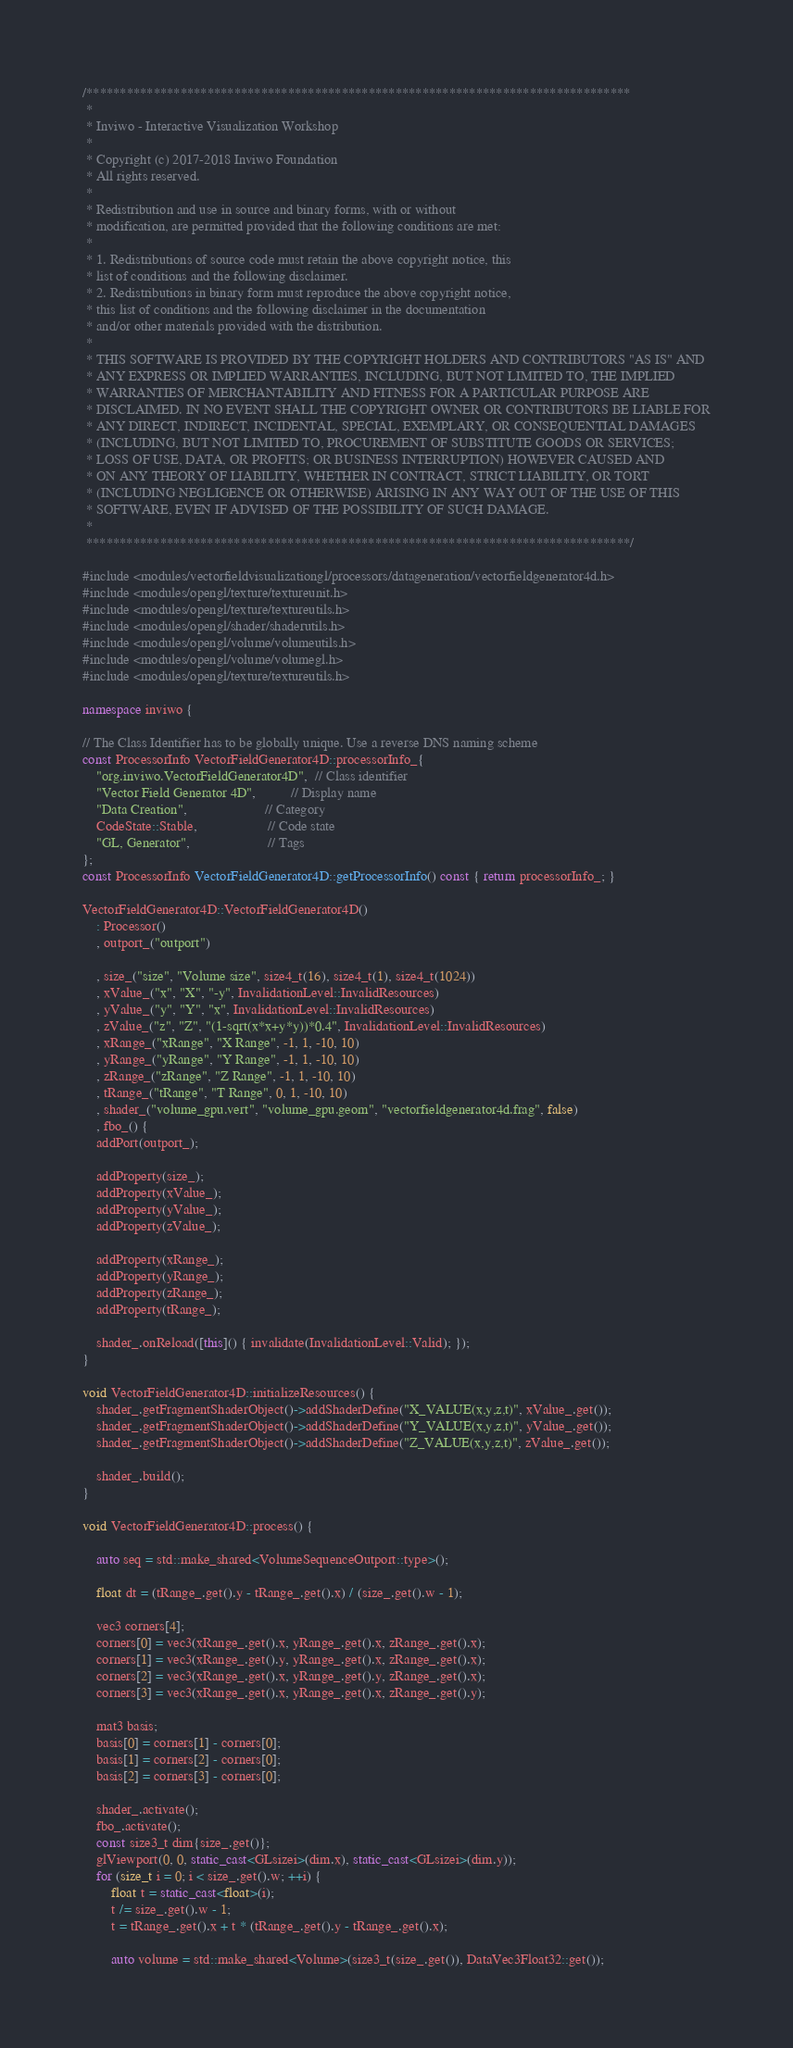<code> <loc_0><loc_0><loc_500><loc_500><_C++_>/*********************************************************************************
 *
 * Inviwo - Interactive Visualization Workshop
 *
 * Copyright (c) 2017-2018 Inviwo Foundation
 * All rights reserved.
 *
 * Redistribution and use in source and binary forms, with or without
 * modification, are permitted provided that the following conditions are met:
 *
 * 1. Redistributions of source code must retain the above copyright notice, this
 * list of conditions and the following disclaimer.
 * 2. Redistributions in binary form must reproduce the above copyright notice,
 * this list of conditions and the following disclaimer in the documentation
 * and/or other materials provided with the distribution.
 *
 * THIS SOFTWARE IS PROVIDED BY THE COPYRIGHT HOLDERS AND CONTRIBUTORS "AS IS" AND
 * ANY EXPRESS OR IMPLIED WARRANTIES, INCLUDING, BUT NOT LIMITED TO, THE IMPLIED
 * WARRANTIES OF MERCHANTABILITY AND FITNESS FOR A PARTICULAR PURPOSE ARE
 * DISCLAIMED. IN NO EVENT SHALL THE COPYRIGHT OWNER OR CONTRIBUTORS BE LIABLE FOR
 * ANY DIRECT, INDIRECT, INCIDENTAL, SPECIAL, EXEMPLARY, OR CONSEQUENTIAL DAMAGES
 * (INCLUDING, BUT NOT LIMITED TO, PROCUREMENT OF SUBSTITUTE GOODS OR SERVICES;
 * LOSS OF USE, DATA, OR PROFITS; OR BUSINESS INTERRUPTION) HOWEVER CAUSED AND
 * ON ANY THEORY OF LIABILITY, WHETHER IN CONTRACT, STRICT LIABILITY, OR TORT
 * (INCLUDING NEGLIGENCE OR OTHERWISE) ARISING IN ANY WAY OUT OF THE USE OF THIS
 * SOFTWARE, EVEN IF ADVISED OF THE POSSIBILITY OF SUCH DAMAGE.
 *
 *********************************************************************************/

#include <modules/vectorfieldvisualizationgl/processors/datageneration/vectorfieldgenerator4d.h>
#include <modules/opengl/texture/textureunit.h>
#include <modules/opengl/texture/textureutils.h>
#include <modules/opengl/shader/shaderutils.h>
#include <modules/opengl/volume/volumeutils.h>
#include <modules/opengl/volume/volumegl.h>
#include <modules/opengl/texture/textureutils.h>

namespace inviwo {

// The Class Identifier has to be globally unique. Use a reverse DNS naming scheme
const ProcessorInfo VectorFieldGenerator4D::processorInfo_{
    "org.inviwo.VectorFieldGenerator4D",  // Class identifier
    "Vector Field Generator 4D",          // Display name
    "Data Creation",                      // Category
    CodeState::Stable,                    // Code state
    "GL, Generator",                      // Tags
};
const ProcessorInfo VectorFieldGenerator4D::getProcessorInfo() const { return processorInfo_; }

VectorFieldGenerator4D::VectorFieldGenerator4D()
    : Processor()
    , outport_("outport")

    , size_("size", "Volume size", size4_t(16), size4_t(1), size4_t(1024))
    , xValue_("x", "X", "-y", InvalidationLevel::InvalidResources)
    , yValue_("y", "Y", "x", InvalidationLevel::InvalidResources)
    , zValue_("z", "Z", "(1-sqrt(x*x+y*y))*0.4", InvalidationLevel::InvalidResources)
    , xRange_("xRange", "X Range", -1, 1, -10, 10)
    , yRange_("yRange", "Y Range", -1, 1, -10, 10)
    , zRange_("zRange", "Z Range", -1, 1, -10, 10)
    , tRange_("tRange", "T Range", 0, 1, -10, 10)
    , shader_("volume_gpu.vert", "volume_gpu.geom", "vectorfieldgenerator4d.frag", false)
    , fbo_() {
    addPort(outport_);

    addProperty(size_);
    addProperty(xValue_);
    addProperty(yValue_);
    addProperty(zValue_);

    addProperty(xRange_);
    addProperty(yRange_);
    addProperty(zRange_);
    addProperty(tRange_);

    shader_.onReload([this]() { invalidate(InvalidationLevel::Valid); });
}

void VectorFieldGenerator4D::initializeResources() {
    shader_.getFragmentShaderObject()->addShaderDefine("X_VALUE(x,y,z,t)", xValue_.get());
    shader_.getFragmentShaderObject()->addShaderDefine("Y_VALUE(x,y,z,t)", yValue_.get());
    shader_.getFragmentShaderObject()->addShaderDefine("Z_VALUE(x,y,z,t)", zValue_.get());

    shader_.build();
}

void VectorFieldGenerator4D::process() {

    auto seq = std::make_shared<VolumeSequenceOutport::type>();

    float dt = (tRange_.get().y - tRange_.get().x) / (size_.get().w - 1);

    vec3 corners[4];
    corners[0] = vec3(xRange_.get().x, yRange_.get().x, zRange_.get().x);
    corners[1] = vec3(xRange_.get().y, yRange_.get().x, zRange_.get().x);
    corners[2] = vec3(xRange_.get().x, yRange_.get().y, zRange_.get().x);
    corners[3] = vec3(xRange_.get().x, yRange_.get().x, zRange_.get().y);

    mat3 basis;
    basis[0] = corners[1] - corners[0];
    basis[1] = corners[2] - corners[0];
    basis[2] = corners[3] - corners[0];

    shader_.activate();
    fbo_.activate();
    const size3_t dim{size_.get()};
    glViewport(0, 0, static_cast<GLsizei>(dim.x), static_cast<GLsizei>(dim.y));
    for (size_t i = 0; i < size_.get().w; ++i) {
        float t = static_cast<float>(i);
        t /= size_.get().w - 1;
        t = tRange_.get().x + t * (tRange_.get().y - tRange_.get().x);

        auto volume = std::make_shared<Volume>(size3_t(size_.get()), DataVec3Float32::get());</code> 